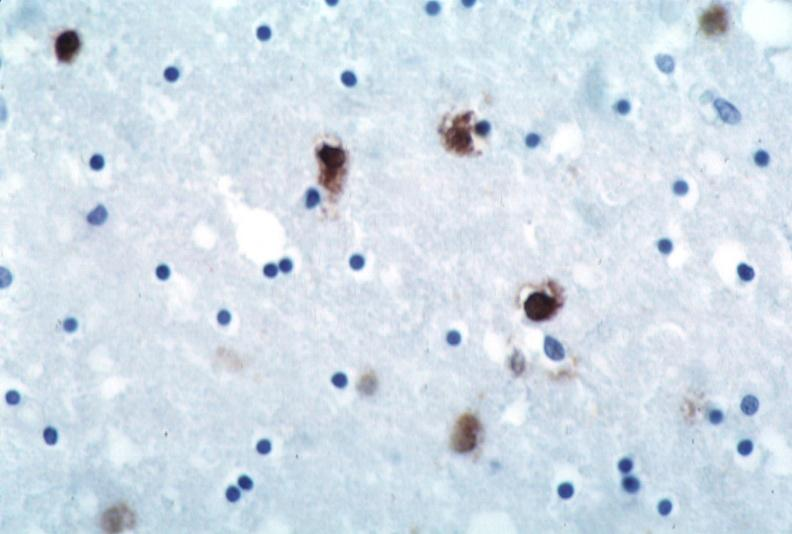what does this image show?
Answer the question using a single word or phrase. Brain 